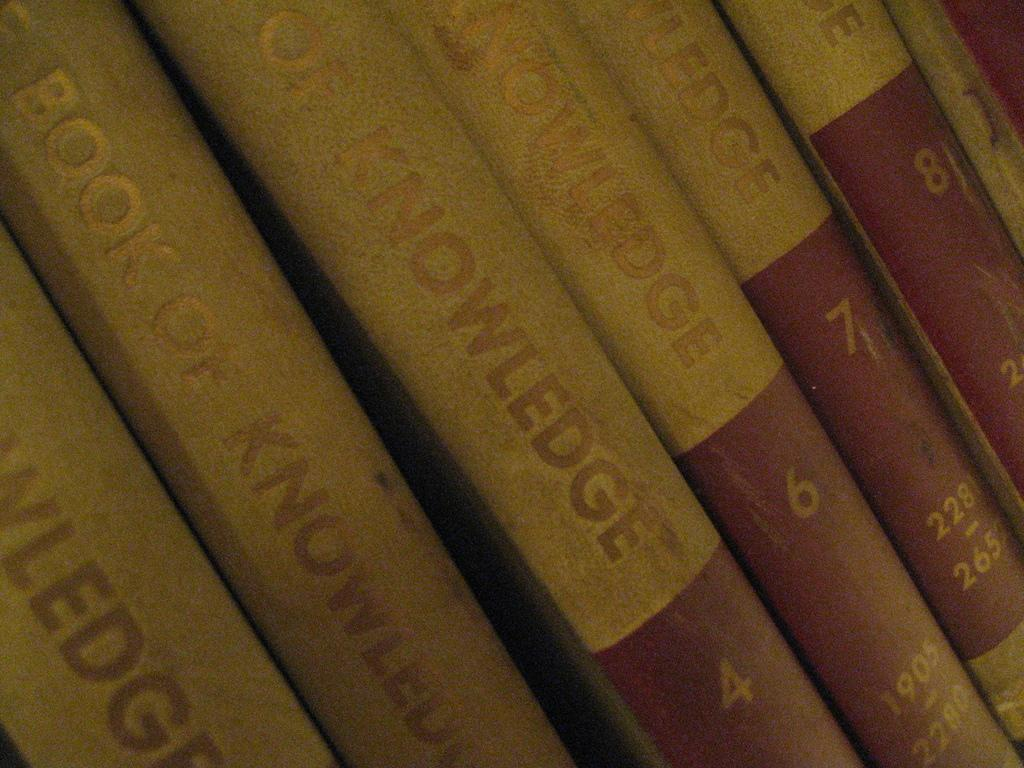<image>
Provide a brief description of the given image. Several books of knowledge are lined up in a row. 